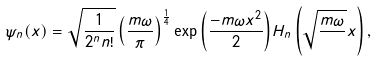Convert formula to latex. <formula><loc_0><loc_0><loc_500><loc_500>\psi _ { n } ( x ) = \sqrt { \frac { 1 } { 2 ^ { n } n ! } } \left ( \frac { m \omega } { \pi } \right ) ^ { \frac { 1 } { 4 } } \exp { \left ( \frac { - m \omega x ^ { 2 } } { 2 } \right ) } H _ { n } \left ( \sqrt { \frac { m \omega } { } } x \right ) ,</formula> 